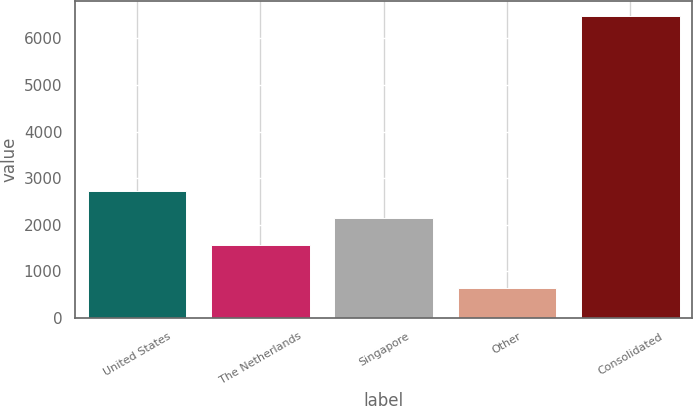Convert chart to OTSL. <chart><loc_0><loc_0><loc_500><loc_500><bar_chart><fcel>United States<fcel>The Netherlands<fcel>Singapore<fcel>Other<fcel>Consolidated<nl><fcel>2732<fcel>1562<fcel>2147<fcel>636<fcel>6486<nl></chart> 